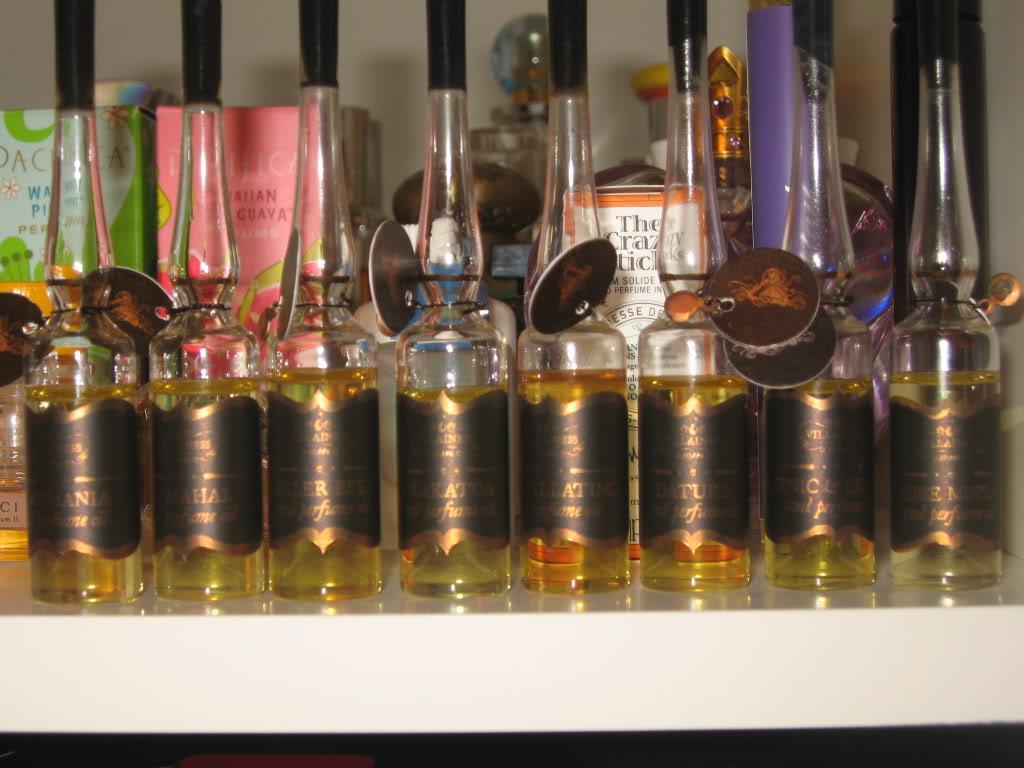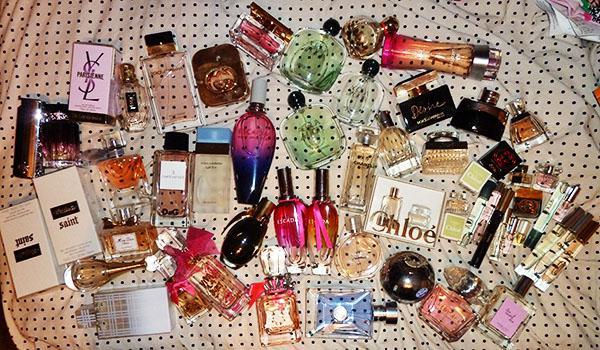The first image is the image on the left, the second image is the image on the right. Examine the images to the left and right. Is the description "There are at least 10 perfume bottles with the same color and style top." accurate? Answer yes or no. No. The first image is the image on the left, the second image is the image on the right. For the images displayed, is the sentence "Two of the perfume bottles are squat and round with rounded, reflective chrome tops." factually correct? Answer yes or no. No. 